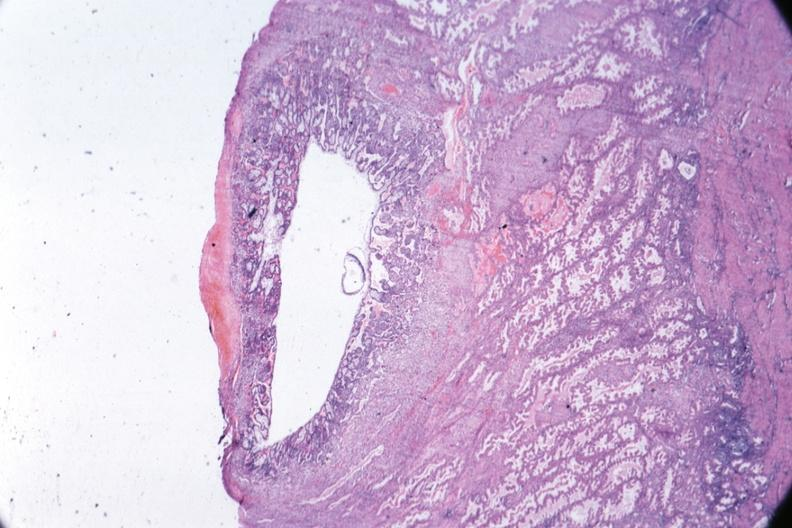what is present?
Answer the question using a single word or phrase. Uterus 